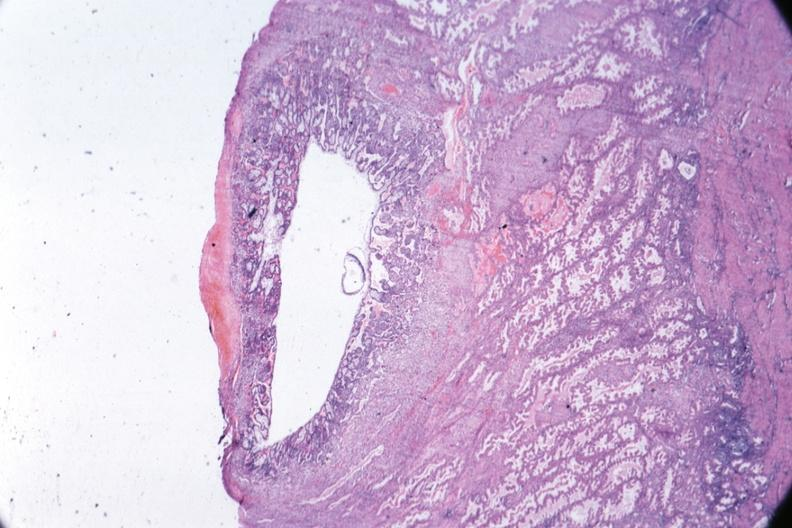what is present?
Answer the question using a single word or phrase. Uterus 